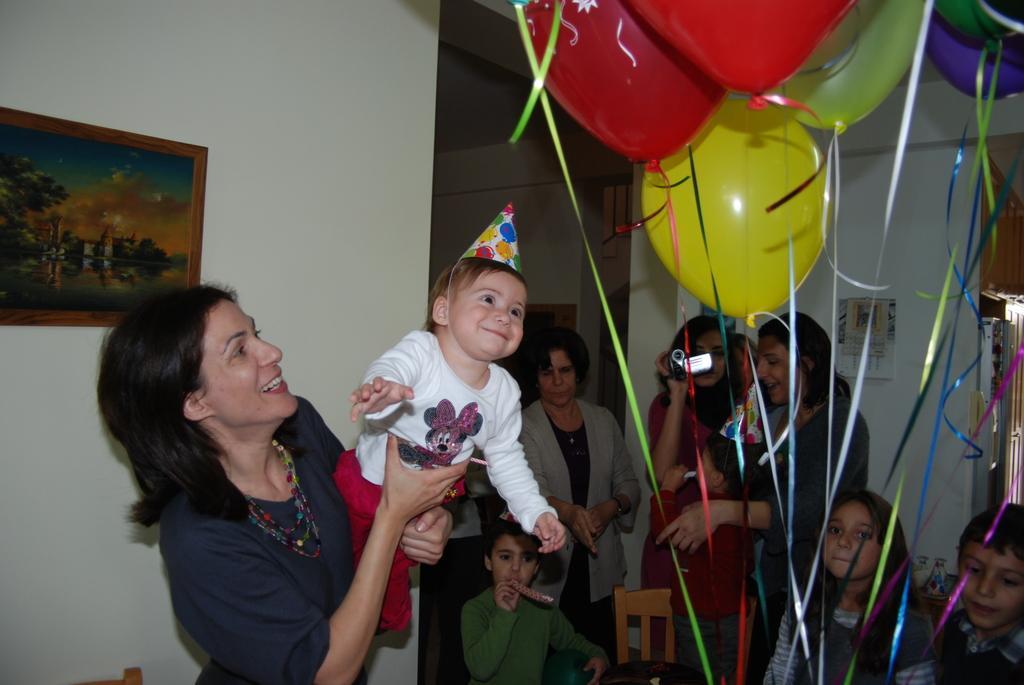In one or two sentences, can you explain what this image depicts? In this image I can see group of people standing, the person in front wearing blue color shirt and holding a baby, and the baby is wearing red and white color dress and I can see multi color balloons. Background I can see a frame attached to the wall and the wall is in white color. 